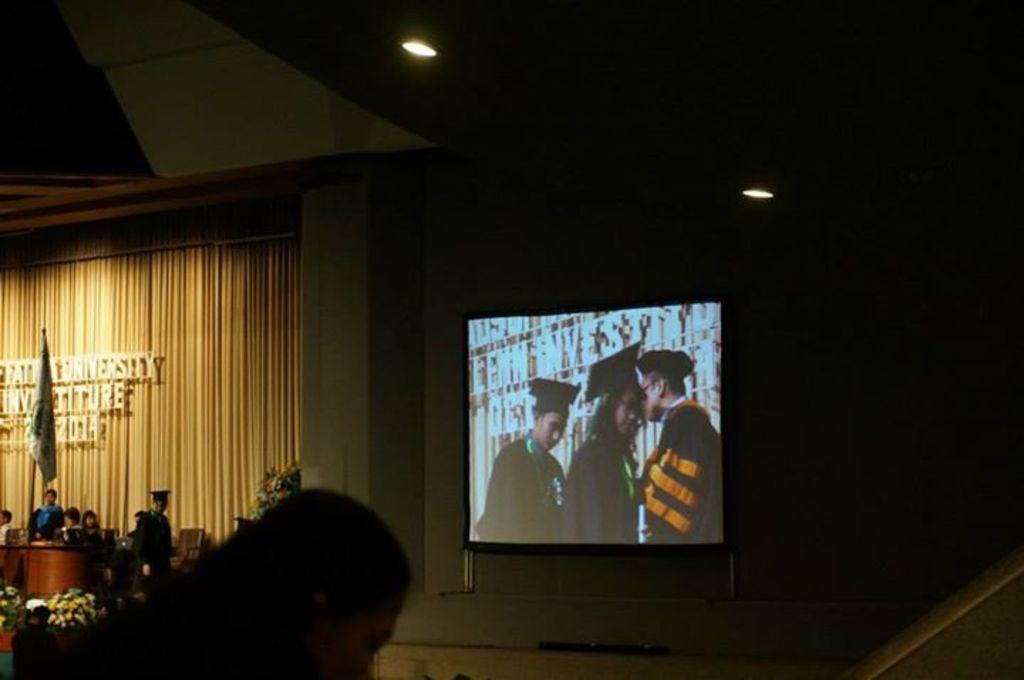In one or two sentences, can you explain what this image depicts? In this image in the center there is a screen. On the left side there are persons sitting and standing, there is a flag and in the background there is a curtain which is yellow in colour and there is some text written in front of the curtain. In the front there is a person. 